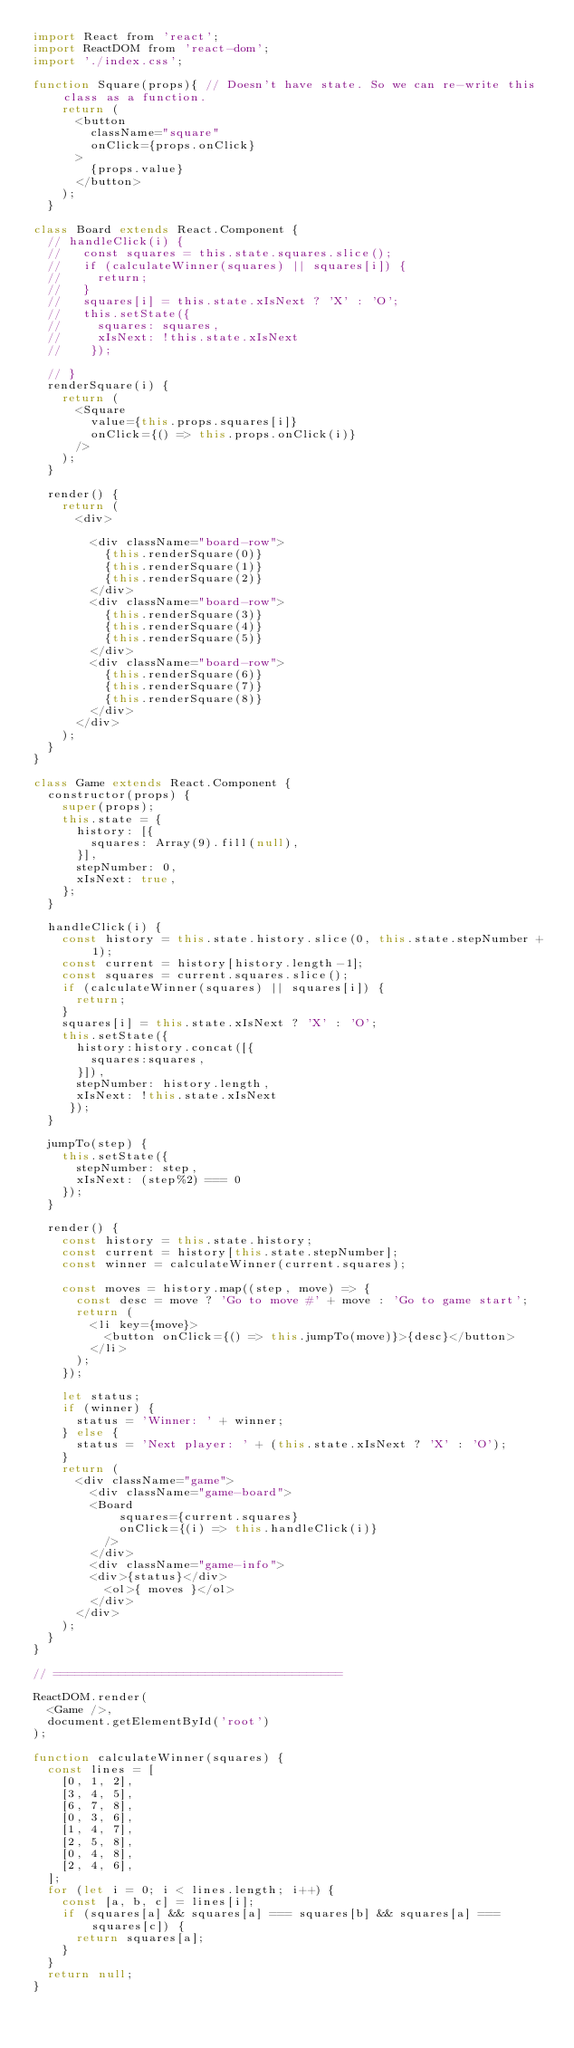<code> <loc_0><loc_0><loc_500><loc_500><_JavaScript_>import React from 'react';
import ReactDOM from 'react-dom';
import './index.css';

function Square(props){ // Doesn't have state. So we can re-write this class as a function.
    return (
      <button
        className="square"
        onClick={props.onClick}
      >
        {props.value}
      </button>
    );
  }

class Board extends React.Component {
  // handleClick(i) {
  //   const squares = this.state.squares.slice();
  //   if (calculateWinner(squares) || squares[i]) {
  //     return;
  //   }
  //   squares[i] = this.state.xIsNext ? 'X' : 'O';
  //   this.setState({ 
  //     squares: squares,
  //     xIsNext: !this.state.xIsNext
  //    });
    
  // }
  renderSquare(i) {
    return (
      <Square
        value={this.props.squares[i]}
        onClick={() => this.props.onClick(i)}
      />
    );
  }

  render() {
    return (
      <div>
        
        <div className="board-row">
          {this.renderSquare(0)}
          {this.renderSquare(1)}
          {this.renderSquare(2)}
        </div>
        <div className="board-row">
          {this.renderSquare(3)}
          {this.renderSquare(4)}
          {this.renderSquare(5)}
        </div>
        <div className="board-row">
          {this.renderSquare(6)}
          {this.renderSquare(7)}
          {this.renderSquare(8)}
        </div>
      </div>
    );
  }
}

class Game extends React.Component {
  constructor(props) {
    super(props);
    this.state = {
      history: [{
        squares: Array(9).fill(null),
      }],
      stepNumber: 0,
      xIsNext: true,
    };
  }

  handleClick(i) {
    const history = this.state.history.slice(0, this.state.stepNumber + 1);
    const current = history[history.length-1];
    const squares = current.squares.slice();
    if (calculateWinner(squares) || squares[i]) {
      return;
    }
    squares[i] = this.state.xIsNext ? 'X' : 'O';
    this.setState({ 
      history:history.concat([{
        squares:squares,
      }]),
      stepNumber: history.length,
      xIsNext: !this.state.xIsNext
     });
  }

  jumpTo(step) {
    this.setState({
      stepNumber: step,
      xIsNext: (step%2) === 0
    });
  }

  render() {
    const history = this.state.history;
    const current = history[this.state.stepNumber];
    const winner = calculateWinner(current.squares);

    const moves = history.map((step, move) => {
      const desc = move ? 'Go to move #' + move : 'Go to game start';
      return (
        <li key={move}>
          <button onClick={() => this.jumpTo(move)}>{desc}</button>
        </li>
      );
    });

    let status;
    if (winner) {
      status = 'Winner: ' + winner;
    } else {
      status = 'Next player: ' + (this.state.xIsNext ? 'X' : 'O');
    }
    return (
      <div className="game">
        <div className="game-board">
        <Board
            squares={current.squares}
            onClick={(i) => this.handleClick(i)}
          />
        </div>
        <div className="game-info">
        <div>{status}</div>
          <ol>{ moves }</ol>
        </div>
      </div>
    );
  }
}

// ========================================

ReactDOM.render(
  <Game />,
  document.getElementById('root')
);

function calculateWinner(squares) {
  const lines = [
    [0, 1, 2],
    [3, 4, 5],
    [6, 7, 8],
    [0, 3, 6],
    [1, 4, 7],
    [2, 5, 8],
    [0, 4, 8],
    [2, 4, 6],
  ];
  for (let i = 0; i < lines.length; i++) {
    const [a, b, c] = lines[i];
    if (squares[a] && squares[a] === squares[b] && squares[a] === squares[c]) {
      return squares[a];
    }
  }
  return null;
}</code> 